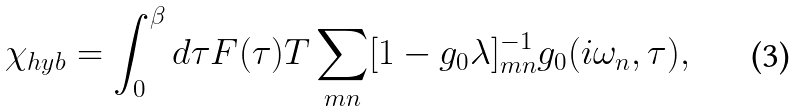Convert formula to latex. <formula><loc_0><loc_0><loc_500><loc_500>\chi _ { h y b } = \int _ { 0 } ^ { \beta } d \tau F ( \tau ) T \sum _ { m n } [ 1 - g _ { 0 } \lambda ] ^ { - 1 } _ { m n } g _ { 0 } ( i \omega _ { n } , \tau ) ,</formula> 